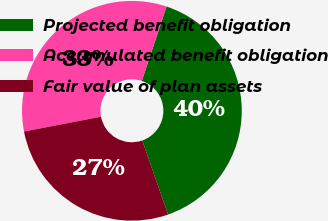Convert chart. <chart><loc_0><loc_0><loc_500><loc_500><pie_chart><fcel>Projected benefit obligation<fcel>Accumulated benefit obligation<fcel>Fair value of plan assets<nl><fcel>39.55%<fcel>33.13%<fcel>27.32%<nl></chart> 